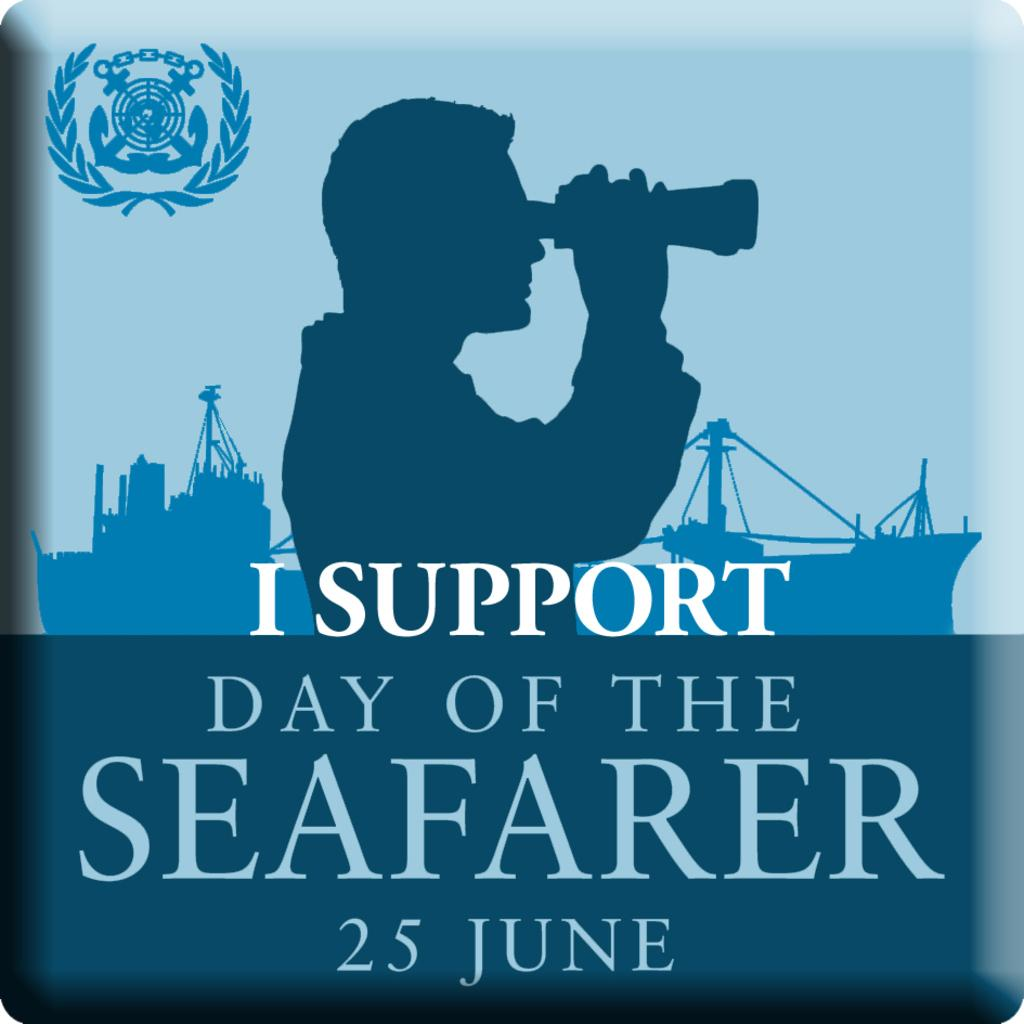What is featured in the image? There is a poster in the image. What is happening in the poster? The poster contains a person holding an object. What else can be found on the poster? The poster includes text. How many fairies are dancing around the bottle in the image? There are no fairies or bottles present in the image; it only features a poster with a person holding an object and text. 